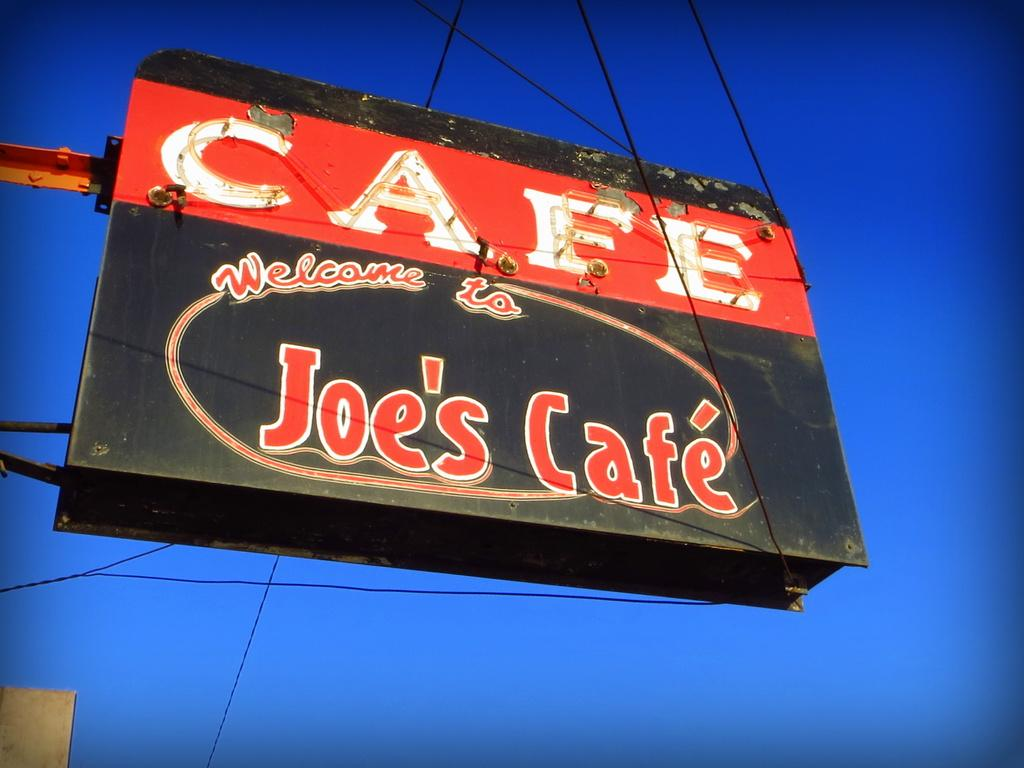<image>
Write a terse but informative summary of the picture. a billboard that says 'cafe welcome to joe's cafe' on it 